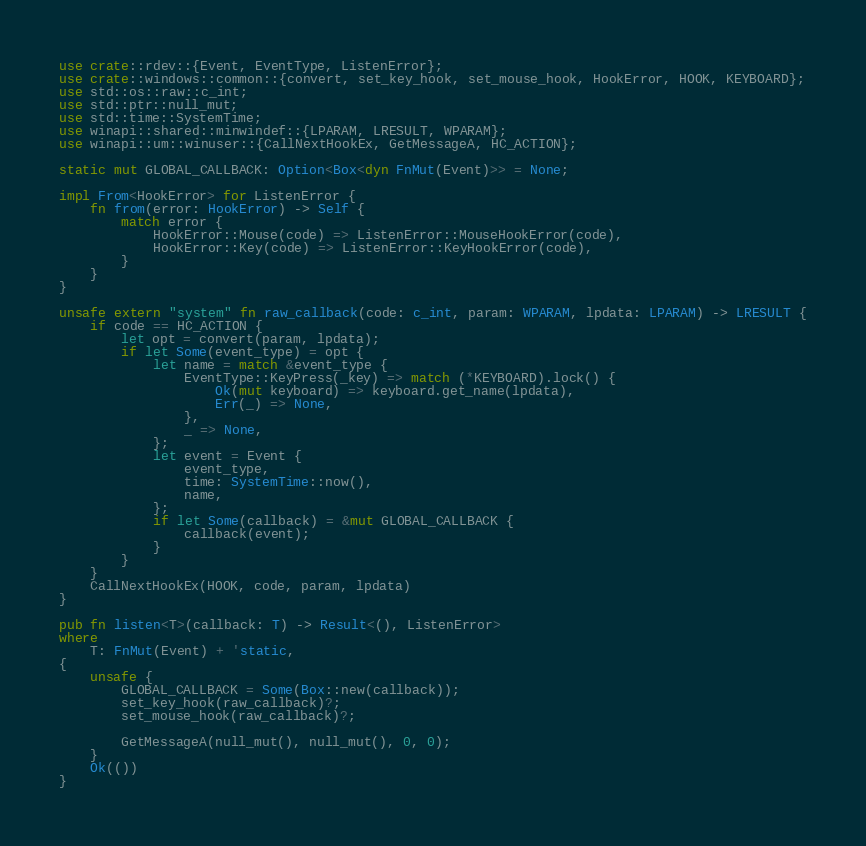<code> <loc_0><loc_0><loc_500><loc_500><_Rust_>use crate::rdev::{Event, EventType, ListenError};
use crate::windows::common::{convert, set_key_hook, set_mouse_hook, HookError, HOOK, KEYBOARD};
use std::os::raw::c_int;
use std::ptr::null_mut;
use std::time::SystemTime;
use winapi::shared::minwindef::{LPARAM, LRESULT, WPARAM};
use winapi::um::winuser::{CallNextHookEx, GetMessageA, HC_ACTION};

static mut GLOBAL_CALLBACK: Option<Box<dyn FnMut(Event)>> = None;

impl From<HookError> for ListenError {
    fn from(error: HookError) -> Self {
        match error {
            HookError::Mouse(code) => ListenError::MouseHookError(code),
            HookError::Key(code) => ListenError::KeyHookError(code),
        }
    }
}

unsafe extern "system" fn raw_callback(code: c_int, param: WPARAM, lpdata: LPARAM) -> LRESULT {
    if code == HC_ACTION {
        let opt = convert(param, lpdata);
        if let Some(event_type) = opt {
            let name = match &event_type {
                EventType::KeyPress(_key) => match (*KEYBOARD).lock() {
                    Ok(mut keyboard) => keyboard.get_name(lpdata),
                    Err(_) => None,
                },
                _ => None,
            };
            let event = Event {
                event_type,
                time: SystemTime::now(),
                name,
            };
            if let Some(callback) = &mut GLOBAL_CALLBACK {
                callback(event);
            }
        }
    }
    CallNextHookEx(HOOK, code, param, lpdata)
}

pub fn listen<T>(callback: T) -> Result<(), ListenError>
where
    T: FnMut(Event) + 'static,
{
    unsafe {
        GLOBAL_CALLBACK = Some(Box::new(callback));
        set_key_hook(raw_callback)?;
        set_mouse_hook(raw_callback)?;

        GetMessageA(null_mut(), null_mut(), 0, 0);
    }
    Ok(())
}
</code> 